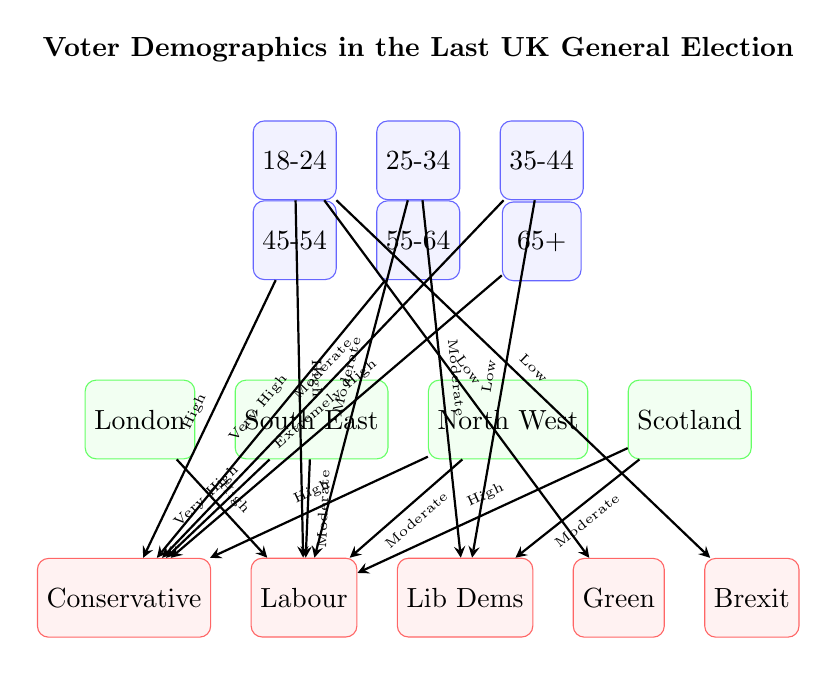What age group shows extremely high support for Conservatives? The diagram indicates that the age group of 55-64 has an "Extremely High" connection to the Conservative party, as shown by the strong arrow leading from that age node to the Conservative party node.
Answer: 55-64 Which location has the highest voting correlation with Labour? The South East location has a "Very High" connection to the Labour party, indicating that it shows the highest correlation among the listed locations in the diagram.
Answer: South East How many age groups are represented in the diagram? The diagram has a total of 6 distinct age groups listed in the upper matrix, representing the ages 18-24 through 65+.
Answer: 6 What is the voting pattern for the 25-34 age group toward Lib Dems? The diagram shows a "Moderate" connection from the 25-34 age group to the Lib Dems, indicating an average level of support for that party from this age group.
Answer: Moderate Which political party does the 45-54 age group show high support for? The diagram indicates that the 45-54 age group has a "High" connection to the Conservative party, meaning they show significant support for it.
Answer: Conservative In which location do the 18-24 year-olds show low support for Brexit? The connection from the 18-24 year-olds to the Brexit party is indicated as "Low," showing that this age group does not strongly align with Brexit in any location, but specifics are not given for locations in the diagram.
Answer: Low What is the relationship between the North West location and the Conservative party? The North West location has a "High" connection to the Conservative party, meaning voters from this area tend to support them significantly.
Answer: High Which age demographic has the lowest likelihood of voting for the Green party? The diagram shows that the 18-24 age group has a "Low" connection to the Green party, indicating minimal support compared to other age groups.
Answer: 18-24 